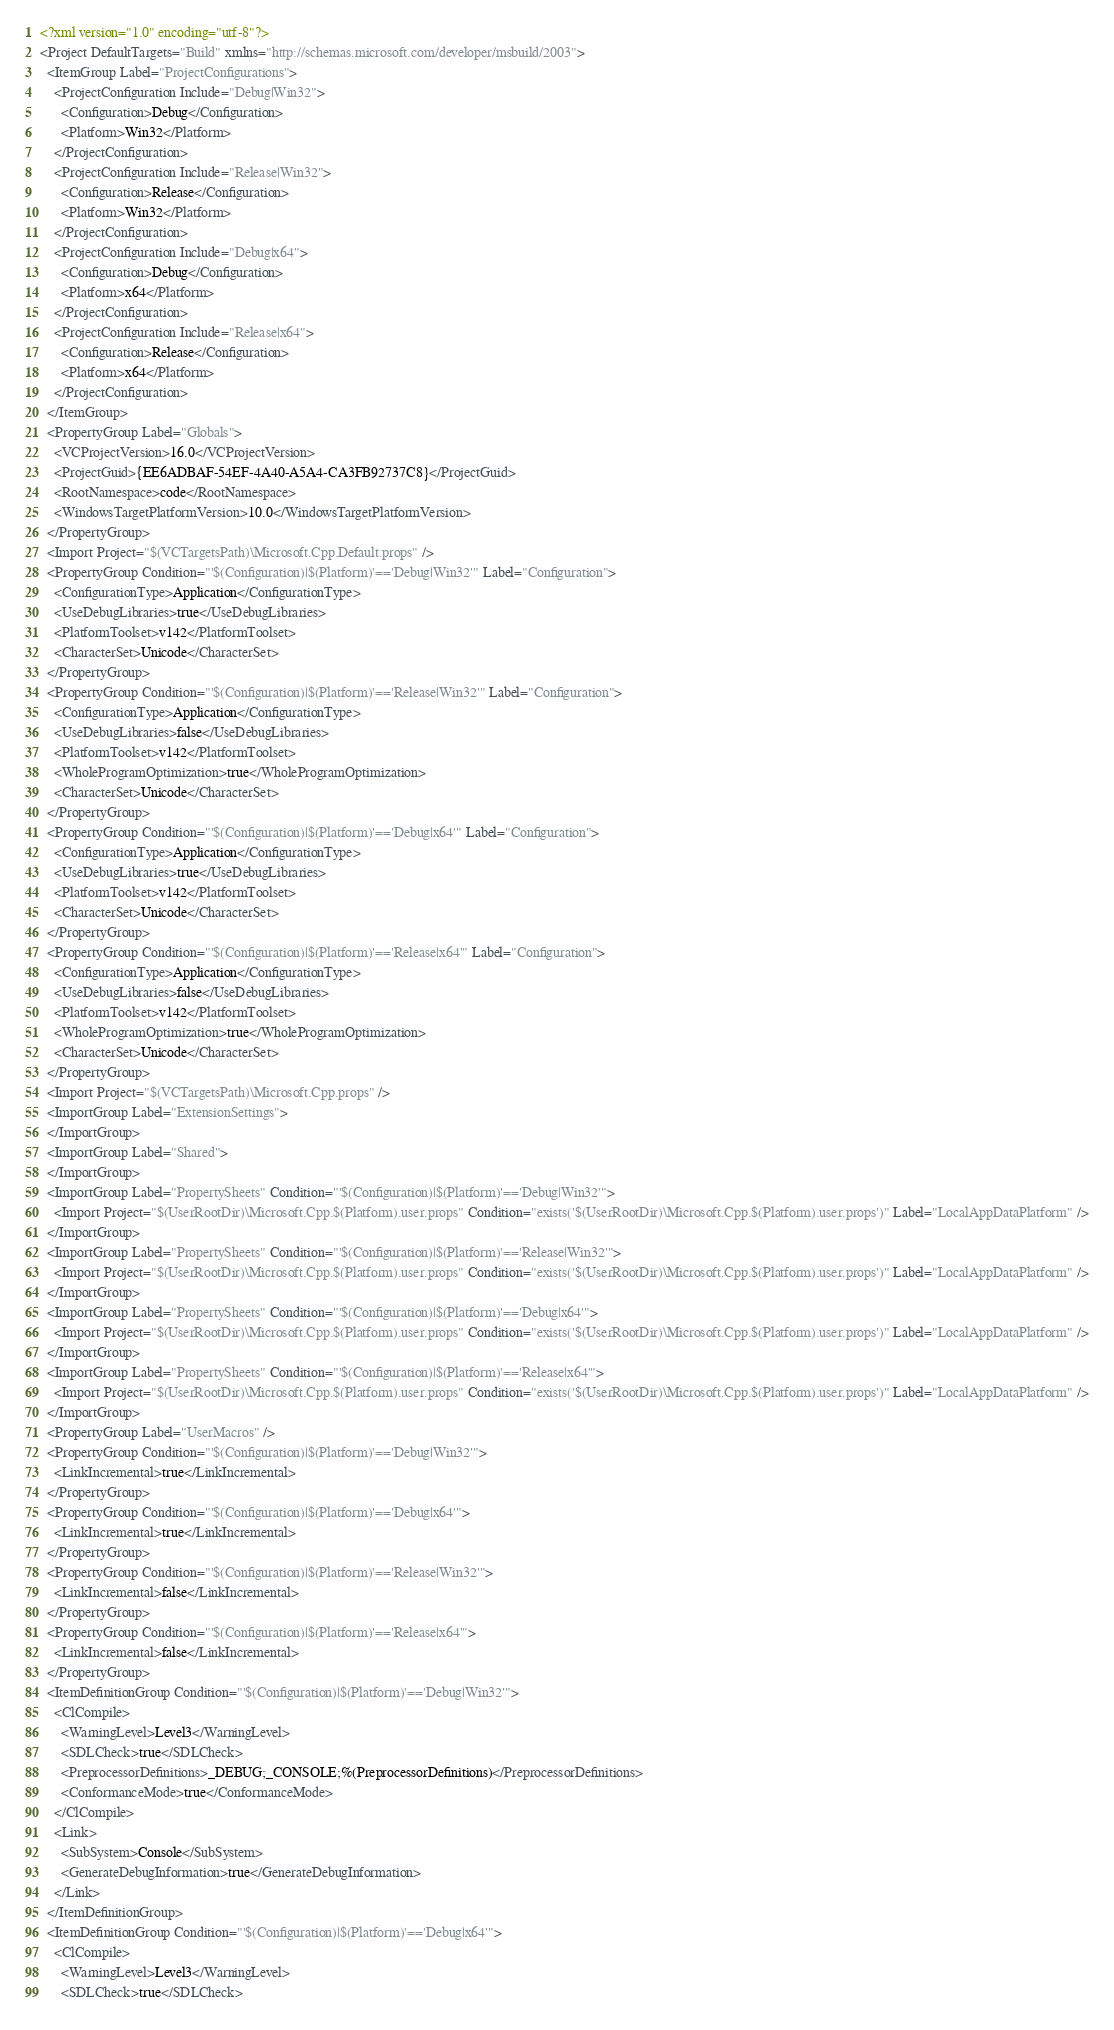Convert code to text. <code><loc_0><loc_0><loc_500><loc_500><_XML_><?xml version="1.0" encoding="utf-8"?>
<Project DefaultTargets="Build" xmlns="http://schemas.microsoft.com/developer/msbuild/2003">
  <ItemGroup Label="ProjectConfigurations">
    <ProjectConfiguration Include="Debug|Win32">
      <Configuration>Debug</Configuration>
      <Platform>Win32</Platform>
    </ProjectConfiguration>
    <ProjectConfiguration Include="Release|Win32">
      <Configuration>Release</Configuration>
      <Platform>Win32</Platform>
    </ProjectConfiguration>
    <ProjectConfiguration Include="Debug|x64">
      <Configuration>Debug</Configuration>
      <Platform>x64</Platform>
    </ProjectConfiguration>
    <ProjectConfiguration Include="Release|x64">
      <Configuration>Release</Configuration>
      <Platform>x64</Platform>
    </ProjectConfiguration>
  </ItemGroup>
  <PropertyGroup Label="Globals">
    <VCProjectVersion>16.0</VCProjectVersion>
    <ProjectGuid>{EE6ADBAF-54EF-4A40-A5A4-CA3FB92737C8}</ProjectGuid>
    <RootNamespace>code</RootNamespace>
    <WindowsTargetPlatformVersion>10.0</WindowsTargetPlatformVersion>
  </PropertyGroup>
  <Import Project="$(VCTargetsPath)\Microsoft.Cpp.Default.props" />
  <PropertyGroup Condition="'$(Configuration)|$(Platform)'=='Debug|Win32'" Label="Configuration">
    <ConfigurationType>Application</ConfigurationType>
    <UseDebugLibraries>true</UseDebugLibraries>
    <PlatformToolset>v142</PlatformToolset>
    <CharacterSet>Unicode</CharacterSet>
  </PropertyGroup>
  <PropertyGroup Condition="'$(Configuration)|$(Platform)'=='Release|Win32'" Label="Configuration">
    <ConfigurationType>Application</ConfigurationType>
    <UseDebugLibraries>false</UseDebugLibraries>
    <PlatformToolset>v142</PlatformToolset>
    <WholeProgramOptimization>true</WholeProgramOptimization>
    <CharacterSet>Unicode</CharacterSet>
  </PropertyGroup>
  <PropertyGroup Condition="'$(Configuration)|$(Platform)'=='Debug|x64'" Label="Configuration">
    <ConfigurationType>Application</ConfigurationType>
    <UseDebugLibraries>true</UseDebugLibraries>
    <PlatformToolset>v142</PlatformToolset>
    <CharacterSet>Unicode</CharacterSet>
  </PropertyGroup>
  <PropertyGroup Condition="'$(Configuration)|$(Platform)'=='Release|x64'" Label="Configuration">
    <ConfigurationType>Application</ConfigurationType>
    <UseDebugLibraries>false</UseDebugLibraries>
    <PlatformToolset>v142</PlatformToolset>
    <WholeProgramOptimization>true</WholeProgramOptimization>
    <CharacterSet>Unicode</CharacterSet>
  </PropertyGroup>
  <Import Project="$(VCTargetsPath)\Microsoft.Cpp.props" />
  <ImportGroup Label="ExtensionSettings">
  </ImportGroup>
  <ImportGroup Label="Shared">
  </ImportGroup>
  <ImportGroup Label="PropertySheets" Condition="'$(Configuration)|$(Platform)'=='Debug|Win32'">
    <Import Project="$(UserRootDir)\Microsoft.Cpp.$(Platform).user.props" Condition="exists('$(UserRootDir)\Microsoft.Cpp.$(Platform).user.props')" Label="LocalAppDataPlatform" />
  </ImportGroup>
  <ImportGroup Label="PropertySheets" Condition="'$(Configuration)|$(Platform)'=='Release|Win32'">
    <Import Project="$(UserRootDir)\Microsoft.Cpp.$(Platform).user.props" Condition="exists('$(UserRootDir)\Microsoft.Cpp.$(Platform).user.props')" Label="LocalAppDataPlatform" />
  </ImportGroup>
  <ImportGroup Label="PropertySheets" Condition="'$(Configuration)|$(Platform)'=='Debug|x64'">
    <Import Project="$(UserRootDir)\Microsoft.Cpp.$(Platform).user.props" Condition="exists('$(UserRootDir)\Microsoft.Cpp.$(Platform).user.props')" Label="LocalAppDataPlatform" />
  </ImportGroup>
  <ImportGroup Label="PropertySheets" Condition="'$(Configuration)|$(Platform)'=='Release|x64'">
    <Import Project="$(UserRootDir)\Microsoft.Cpp.$(Platform).user.props" Condition="exists('$(UserRootDir)\Microsoft.Cpp.$(Platform).user.props')" Label="LocalAppDataPlatform" />
  </ImportGroup>
  <PropertyGroup Label="UserMacros" />
  <PropertyGroup Condition="'$(Configuration)|$(Platform)'=='Debug|Win32'">
    <LinkIncremental>true</LinkIncremental>
  </PropertyGroup>
  <PropertyGroup Condition="'$(Configuration)|$(Platform)'=='Debug|x64'">
    <LinkIncremental>true</LinkIncremental>
  </PropertyGroup>
  <PropertyGroup Condition="'$(Configuration)|$(Platform)'=='Release|Win32'">
    <LinkIncremental>false</LinkIncremental>
  </PropertyGroup>
  <PropertyGroup Condition="'$(Configuration)|$(Platform)'=='Release|x64'">
    <LinkIncremental>false</LinkIncremental>
  </PropertyGroup>
  <ItemDefinitionGroup Condition="'$(Configuration)|$(Platform)'=='Debug|Win32'">
    <ClCompile>
      <WarningLevel>Level3</WarningLevel>
      <SDLCheck>true</SDLCheck>
      <PreprocessorDefinitions>_DEBUG;_CONSOLE;%(PreprocessorDefinitions)</PreprocessorDefinitions>
      <ConformanceMode>true</ConformanceMode>
    </ClCompile>
    <Link>
      <SubSystem>Console</SubSystem>
      <GenerateDebugInformation>true</GenerateDebugInformation>
    </Link>
  </ItemDefinitionGroup>
  <ItemDefinitionGroup Condition="'$(Configuration)|$(Platform)'=='Debug|x64'">
    <ClCompile>
      <WarningLevel>Level3</WarningLevel>
      <SDLCheck>true</SDLCheck></code> 